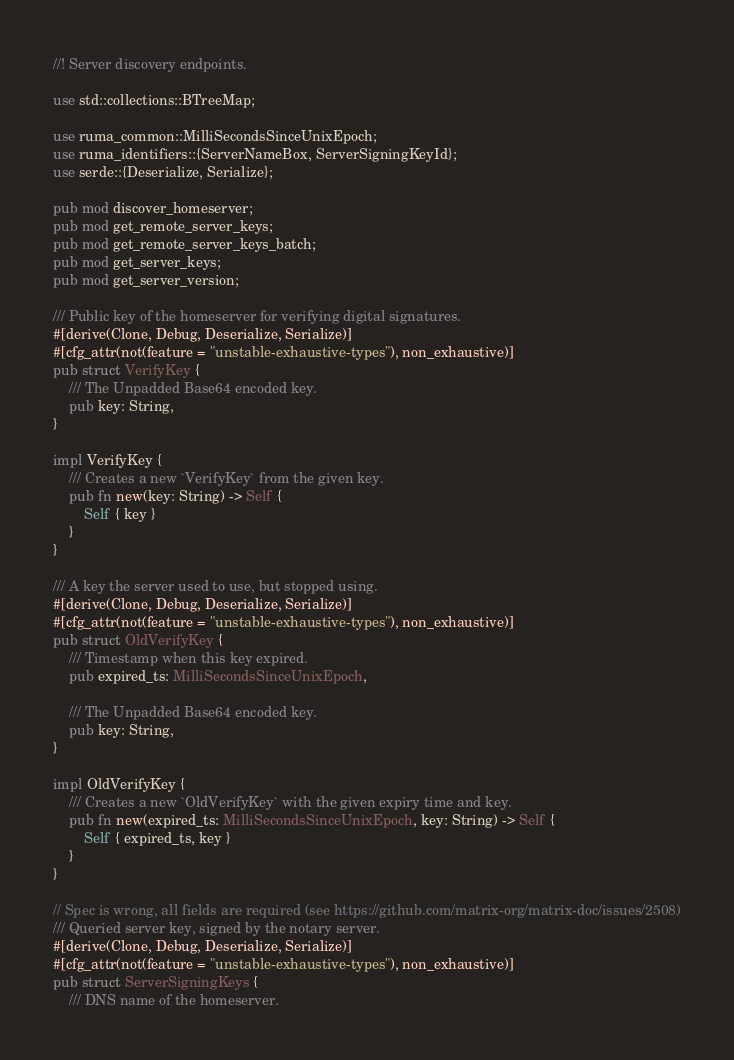<code> <loc_0><loc_0><loc_500><loc_500><_Rust_>//! Server discovery endpoints.

use std::collections::BTreeMap;

use ruma_common::MilliSecondsSinceUnixEpoch;
use ruma_identifiers::{ServerNameBox, ServerSigningKeyId};
use serde::{Deserialize, Serialize};

pub mod discover_homeserver;
pub mod get_remote_server_keys;
pub mod get_remote_server_keys_batch;
pub mod get_server_keys;
pub mod get_server_version;

/// Public key of the homeserver for verifying digital signatures.
#[derive(Clone, Debug, Deserialize, Serialize)]
#[cfg_attr(not(feature = "unstable-exhaustive-types"), non_exhaustive)]
pub struct VerifyKey {
    /// The Unpadded Base64 encoded key.
    pub key: String,
}

impl VerifyKey {
    /// Creates a new `VerifyKey` from the given key.
    pub fn new(key: String) -> Self {
        Self { key }
    }
}

/// A key the server used to use, but stopped using.
#[derive(Clone, Debug, Deserialize, Serialize)]
#[cfg_attr(not(feature = "unstable-exhaustive-types"), non_exhaustive)]
pub struct OldVerifyKey {
    /// Timestamp when this key expired.
    pub expired_ts: MilliSecondsSinceUnixEpoch,

    /// The Unpadded Base64 encoded key.
    pub key: String,
}

impl OldVerifyKey {
    /// Creates a new `OldVerifyKey` with the given expiry time and key.
    pub fn new(expired_ts: MilliSecondsSinceUnixEpoch, key: String) -> Self {
        Self { expired_ts, key }
    }
}

// Spec is wrong, all fields are required (see https://github.com/matrix-org/matrix-doc/issues/2508)
/// Queried server key, signed by the notary server.
#[derive(Clone, Debug, Deserialize, Serialize)]
#[cfg_attr(not(feature = "unstable-exhaustive-types"), non_exhaustive)]
pub struct ServerSigningKeys {
    /// DNS name of the homeserver.</code> 